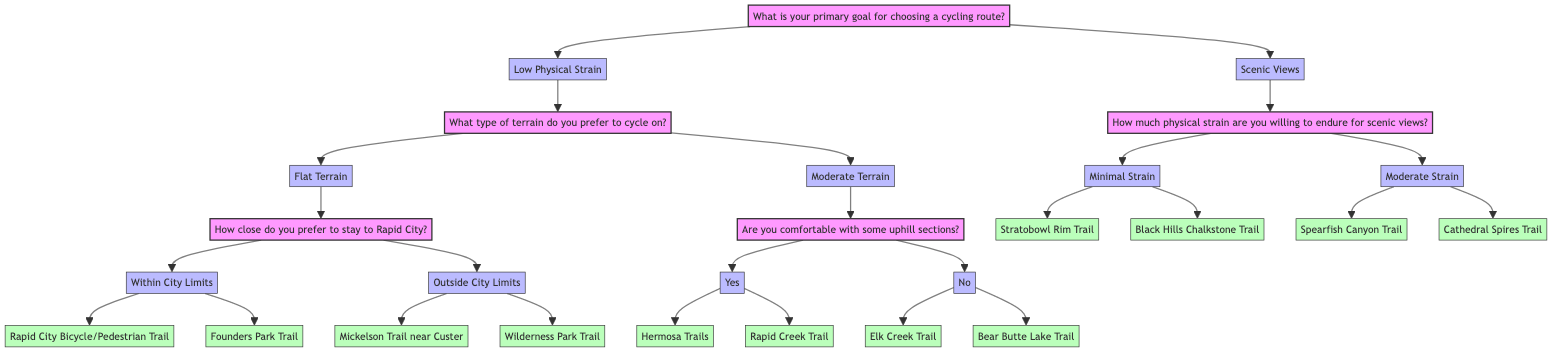What is the primary goal for choosing a cycling route? The diagram starts with a root question, which is the primary goal for choosing a cycling route. The answer options provided are "Low Physical Strain" and "Scenic Views."
Answer: Low Physical Strain or Scenic Views How many routes are available if you choose "Outside City Limits"? If the choice is made for "Outside City Limits" under the "Flat Terrain" option, there are two routes listed: "Mickelson Trail (near Custer)" and "Wilderness Park Trail." Counting these gives a total of two routes available.
Answer: 2 What terrains are available under "Low Physical Strain"? The "Low Physical Strain" option leads to a question about preferred terrain, which provides two choices: "Flat Terrain" and "Moderate Terrain." Thus, the answer is based on the options presented directly under this category.
Answer: Flat Terrain and Moderate Terrain What routes do you get if you choose "Yes" for uphill sections? Choosing "Yes" in response to "Are you comfortable with some uphill sections?" under "Moderate Terrain" leads to two routes: "Hermosa Trails" and "Rapid Creek Trail." These routes are directly listed as options from this node.
Answer: Hermosa Trails and Rapid Creek Trail If you choose "Minimal Strain," what are the available cycling routes? Selecting "Minimal Strain" for the question about how much strain you are willing to endure for scenic views leads to two listed routes: "Stratobowl Rim Trail" and "Black Hills Chalkstone Trail." These are specifically the routes listed under this option.
Answer: Stratobowl Rim Trail and Black Hills Chalkstone Trail What is the relationship between "Scenic Views" and "Moderate Strain"? "Scenic Views" is a primary goal option, and under this, "Moderate Strain" is an option that leads to the routes "Spearfish Canyon Trail" and "Cathedral Spires Trail." The relationship here is that "Moderate Strain" is a choice available under the main category of "Scenic Views."
Answer: Moderate Strain leads to more routes Which route is associated with "Within City Limits"? The option "Within City Limits" under "Flat Terrain" provides two specific routes, which are "Rapid City Bicycle/Pedestrian Trail" and "Founders Park Trail." Selecting this option directly gives associated routes listed in the diagram.
Answer: Rapid City Bicycle/Pedestrian Trail or Founders Park Trail 